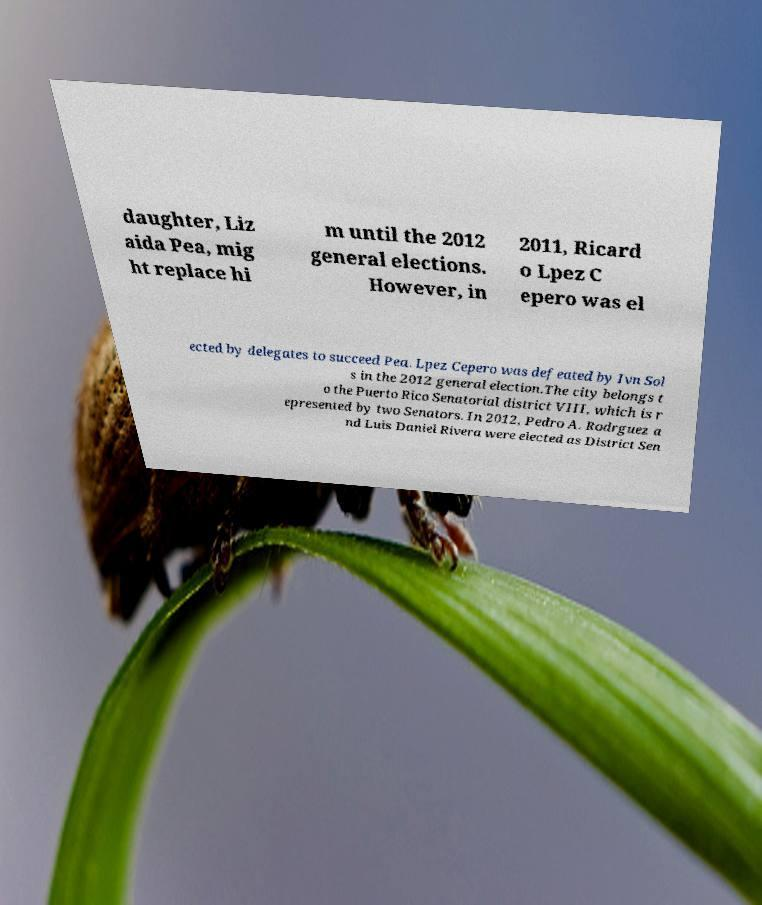What messages or text are displayed in this image? I need them in a readable, typed format. daughter, Liz aida Pea, mig ht replace hi m until the 2012 general elections. However, in 2011, Ricard o Lpez C epero was el ected by delegates to succeed Pea. Lpez Cepero was defeated by Ivn Sol s in the 2012 general election.The city belongs t o the Puerto Rico Senatorial district VIII, which is r epresented by two Senators. In 2012, Pedro A. Rodrguez a nd Luis Daniel Rivera were elected as District Sen 